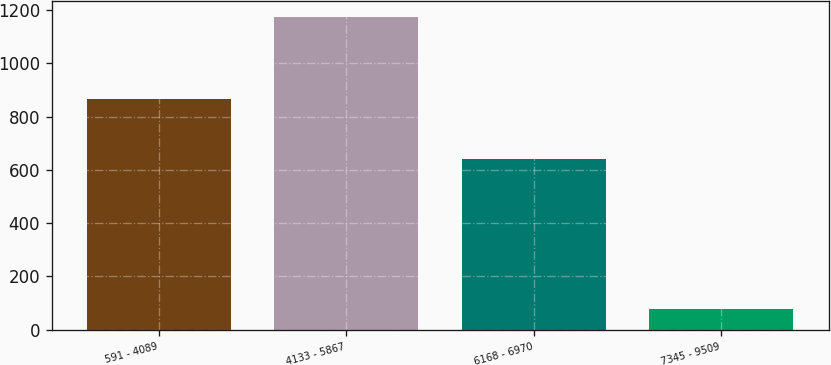<chart> <loc_0><loc_0><loc_500><loc_500><bar_chart><fcel>591 - 4089<fcel>4133 - 5867<fcel>6168 - 6970<fcel>7345 - 9509<nl><fcel>868<fcel>1175<fcel>641<fcel>78<nl></chart> 